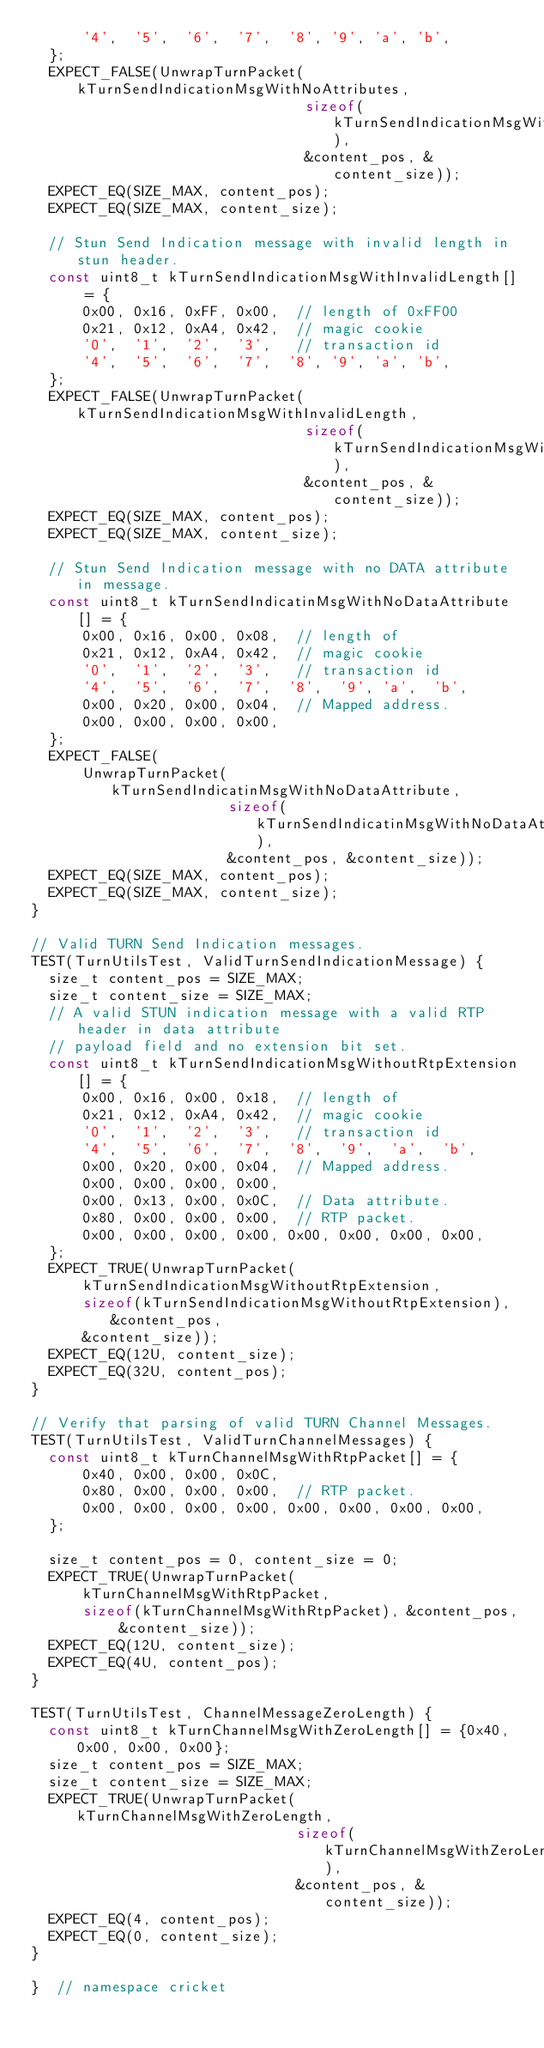<code> <loc_0><loc_0><loc_500><loc_500><_C++_>      '4',  '5',  '6',  '7',  '8', '9', 'a', 'b',
  };
  EXPECT_FALSE(UnwrapTurnPacket(kTurnSendIndicationMsgWithNoAttributes,
                                sizeof(kTurnSendIndicationMsgWithNoAttributes),
                                &content_pos, &content_size));
  EXPECT_EQ(SIZE_MAX, content_pos);
  EXPECT_EQ(SIZE_MAX, content_size);

  // Stun Send Indication message with invalid length in stun header.
  const uint8_t kTurnSendIndicationMsgWithInvalidLength[] = {
      0x00, 0x16, 0xFF, 0x00,  // length of 0xFF00
      0x21, 0x12, 0xA4, 0x42,  // magic cookie
      '0',  '1',  '2',  '3',   // transaction id
      '4',  '5',  '6',  '7',  '8', '9', 'a', 'b',
  };
  EXPECT_FALSE(UnwrapTurnPacket(kTurnSendIndicationMsgWithInvalidLength,
                                sizeof(kTurnSendIndicationMsgWithInvalidLength),
                                &content_pos, &content_size));
  EXPECT_EQ(SIZE_MAX, content_pos);
  EXPECT_EQ(SIZE_MAX, content_size);

  // Stun Send Indication message with no DATA attribute in message.
  const uint8_t kTurnSendIndicatinMsgWithNoDataAttribute[] = {
      0x00, 0x16, 0x00, 0x08,  // length of
      0x21, 0x12, 0xA4, 0x42,  // magic cookie
      '0',  '1',  '2',  '3',   // transaction id
      '4',  '5',  '6',  '7',  '8',  '9', 'a',  'b',
      0x00, 0x20, 0x00, 0x04,  // Mapped address.
      0x00, 0x00, 0x00, 0x00,
  };
  EXPECT_FALSE(
      UnwrapTurnPacket(kTurnSendIndicatinMsgWithNoDataAttribute,
                       sizeof(kTurnSendIndicatinMsgWithNoDataAttribute),
                       &content_pos, &content_size));
  EXPECT_EQ(SIZE_MAX, content_pos);
  EXPECT_EQ(SIZE_MAX, content_size);
}

// Valid TURN Send Indication messages.
TEST(TurnUtilsTest, ValidTurnSendIndicationMessage) {
  size_t content_pos = SIZE_MAX;
  size_t content_size = SIZE_MAX;
  // A valid STUN indication message with a valid RTP header in data attribute
  // payload field and no extension bit set.
  const uint8_t kTurnSendIndicationMsgWithoutRtpExtension[] = {
      0x00, 0x16, 0x00, 0x18,  // length of
      0x21, 0x12, 0xA4, 0x42,  // magic cookie
      '0',  '1',  '2',  '3',   // transaction id
      '4',  '5',  '6',  '7',  '8',  '9',  'a',  'b',
      0x00, 0x20, 0x00, 0x04,  // Mapped address.
      0x00, 0x00, 0x00, 0x00,
      0x00, 0x13, 0x00, 0x0C,  // Data attribute.
      0x80, 0x00, 0x00, 0x00,  // RTP packet.
      0x00, 0x00, 0x00, 0x00, 0x00, 0x00, 0x00, 0x00,
  };
  EXPECT_TRUE(UnwrapTurnPacket(
      kTurnSendIndicationMsgWithoutRtpExtension,
      sizeof(kTurnSendIndicationMsgWithoutRtpExtension), &content_pos,
      &content_size));
  EXPECT_EQ(12U, content_size);
  EXPECT_EQ(32U, content_pos);
}

// Verify that parsing of valid TURN Channel Messages.
TEST(TurnUtilsTest, ValidTurnChannelMessages) {
  const uint8_t kTurnChannelMsgWithRtpPacket[] = {
      0x40, 0x00, 0x00, 0x0C,
      0x80, 0x00, 0x00, 0x00,  // RTP packet.
      0x00, 0x00, 0x00, 0x00, 0x00, 0x00, 0x00, 0x00,
  };

  size_t content_pos = 0, content_size = 0;
  EXPECT_TRUE(UnwrapTurnPacket(
      kTurnChannelMsgWithRtpPacket,
      sizeof(kTurnChannelMsgWithRtpPacket), &content_pos, &content_size));
  EXPECT_EQ(12U, content_size);
  EXPECT_EQ(4U, content_pos);
}

TEST(TurnUtilsTest, ChannelMessageZeroLength) {
  const uint8_t kTurnChannelMsgWithZeroLength[] = {0x40, 0x00, 0x00, 0x00};
  size_t content_pos = SIZE_MAX;
  size_t content_size = SIZE_MAX;
  EXPECT_TRUE(UnwrapTurnPacket(kTurnChannelMsgWithZeroLength,
                               sizeof(kTurnChannelMsgWithZeroLength),
                               &content_pos, &content_size));
  EXPECT_EQ(4, content_pos);
  EXPECT_EQ(0, content_size);
}

}  // namespace cricket
</code> 